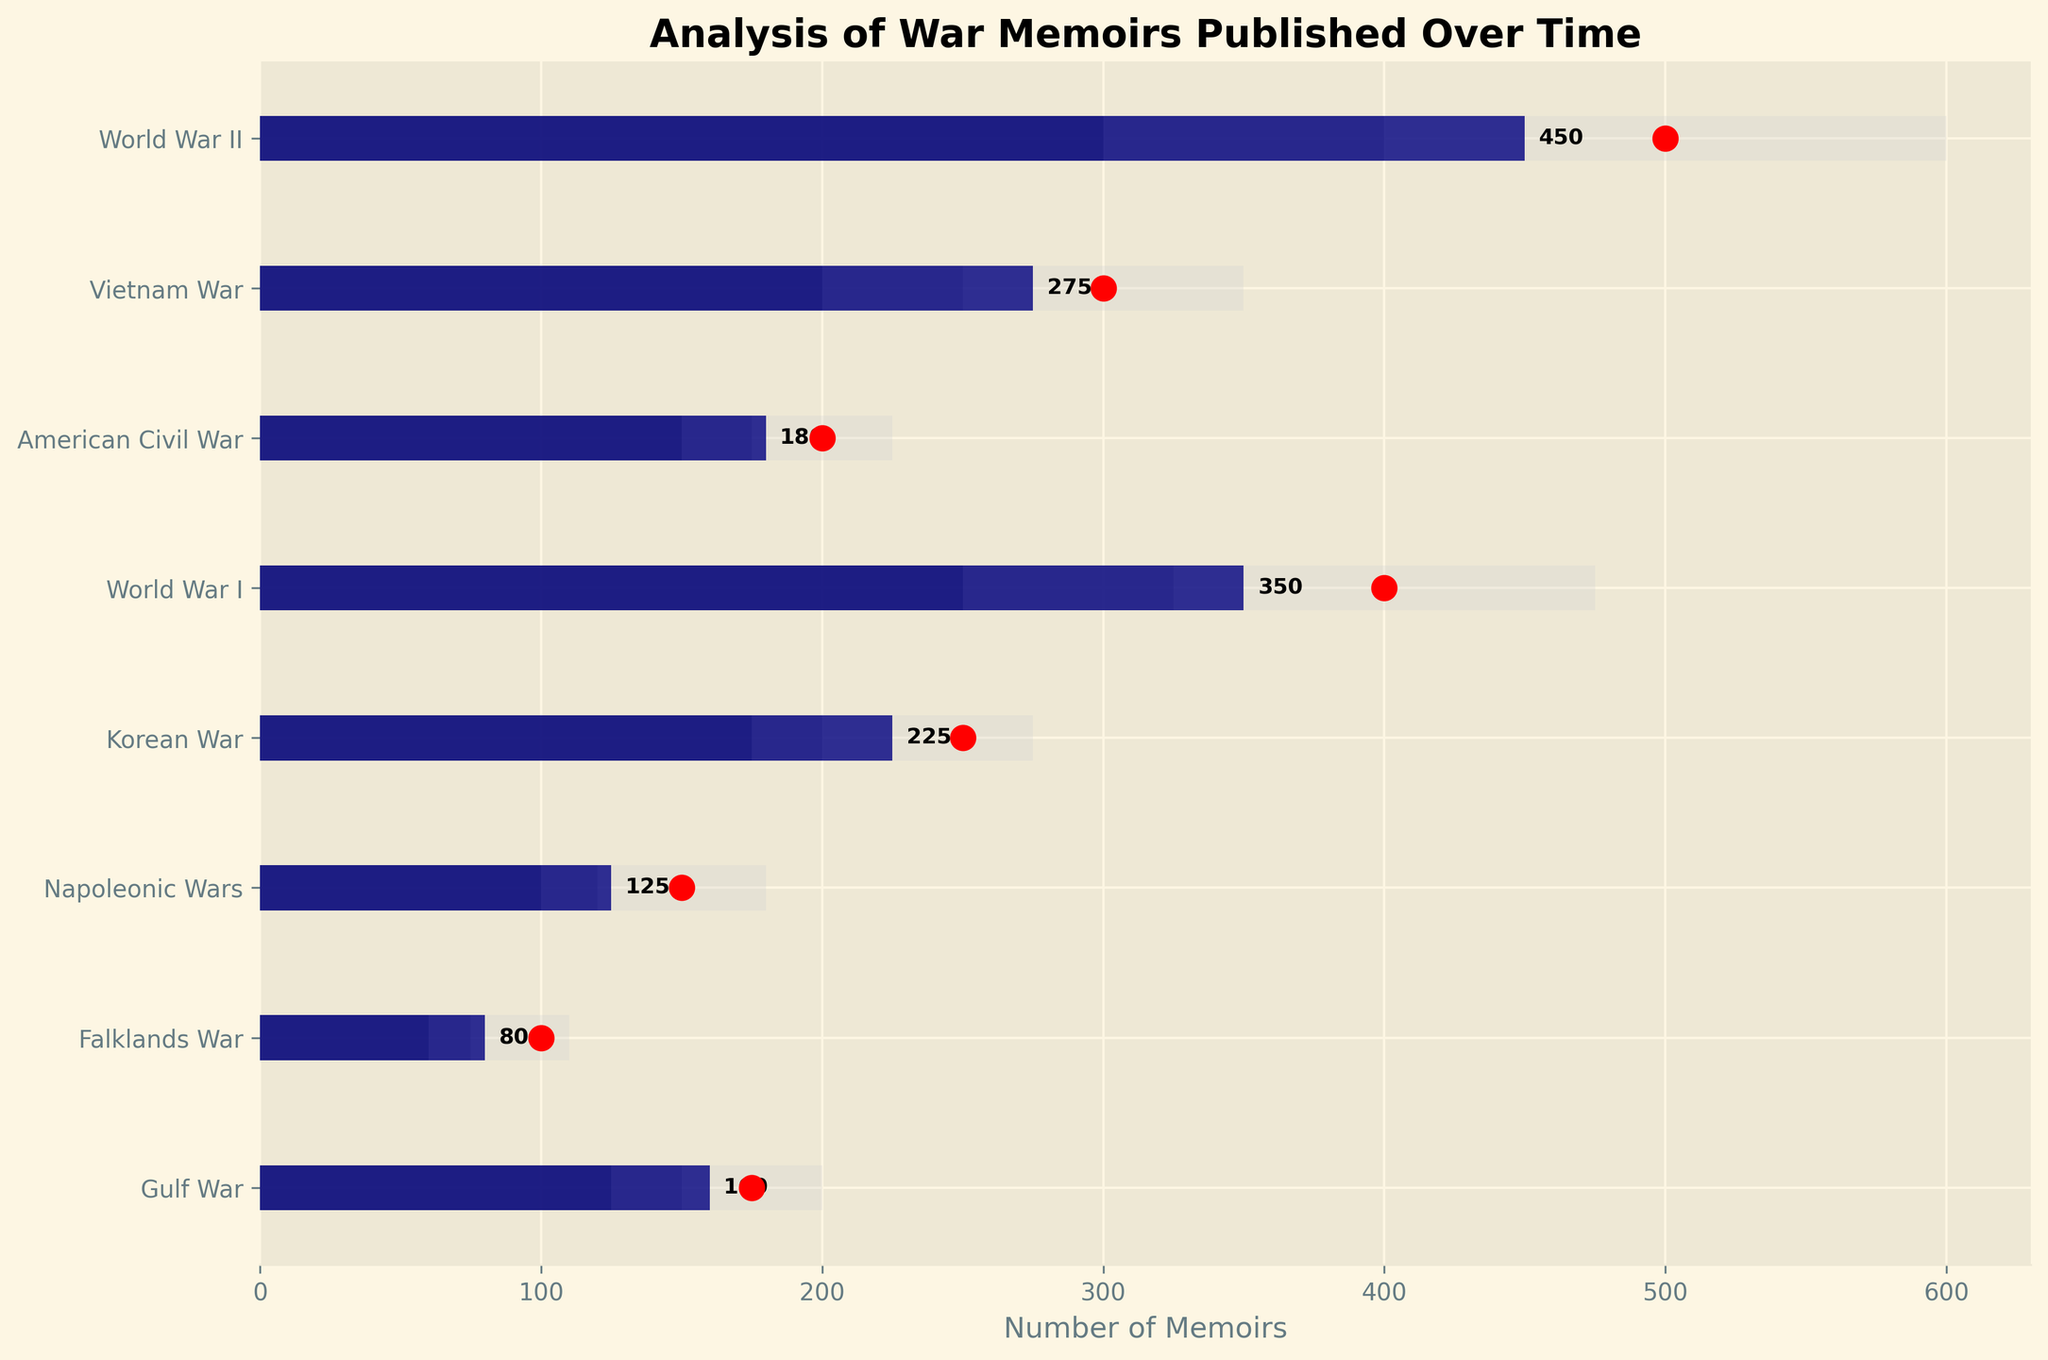What's the title of the figure? The title of the figure is given at the top, and it summarizes the content of the chart.
Answer: Analysis of War Memoirs Published Over Time Which war has the highest number of actual published memoirs? By looking at the length of the navy bars, identify the longest one.
Answer: World War II For the Vietnam War, how does the actual number of published memoirs compare with the target? Compare the length of the navy bar (actuals) for the Vietnam War with the red dot (target).
Answer: The actual number (275) is less than the target (300) Which war has the closest number of actual published memoirs to its target? Compare the distances between the navy bars (actuals) and red dots (targets) for each war, finding the smallest gap.
Answer: Gulf War (275 actuals vs. 300 target, a difference of 25) How many wars have actual published memoirs that are less than their Comparative1 values? Count the number of wars where the navy bar (actuals) is shorter than the darkest grey bar (Comparative1).
Answer: All wars (8) What's the average target number of memoirs across all the wars? Sum the target values and then divide by the number of wars. Target values: 500, 300, 200, 400, 250, 150, 100, 175. Total: 2075. Number of wars: 8. Average: 2075/8.
Answer: 259.375 Which conflict has the smallest range between Comparative1 and Comparative3? Calculate the range (Comparative3 - Comparative1) for each war and identify the smallest. For example, World War II: 600 - 300 = 300. Calculate similarly for others.
Answer: American Civil War (225 - 150 = 75) What's the total number of actual published memoirs for World War I, World War II, and the Korean War combined? Add the actual numbers for these three wars. World War I (350) + World War II (450) + Korean War (225). Sum: 350 + 450 + 225.
Answer: 1025 What percentage of the target has the Falklands War achieved in actual published memoirs? Divide the actual number by the target number and multiply by 100 to get the percentage. Actual: 80, Target: 100. (80 / 100) * 100.
Answer: 80% Which war has the lowest number of memoirs in its Comparative2 category? Look at the middle grey bars (Comparative2) and identify the shortest one.
Answer: Falklands War Which war has the greatest difference between Comparative1 and actual published memoirs? Calculate the difference between Comparative1 and actuals for each war, finding the largest. For example, World War II: 450 - 300 = 150. Calculate similarly for others.
Answer: World War II (150) 